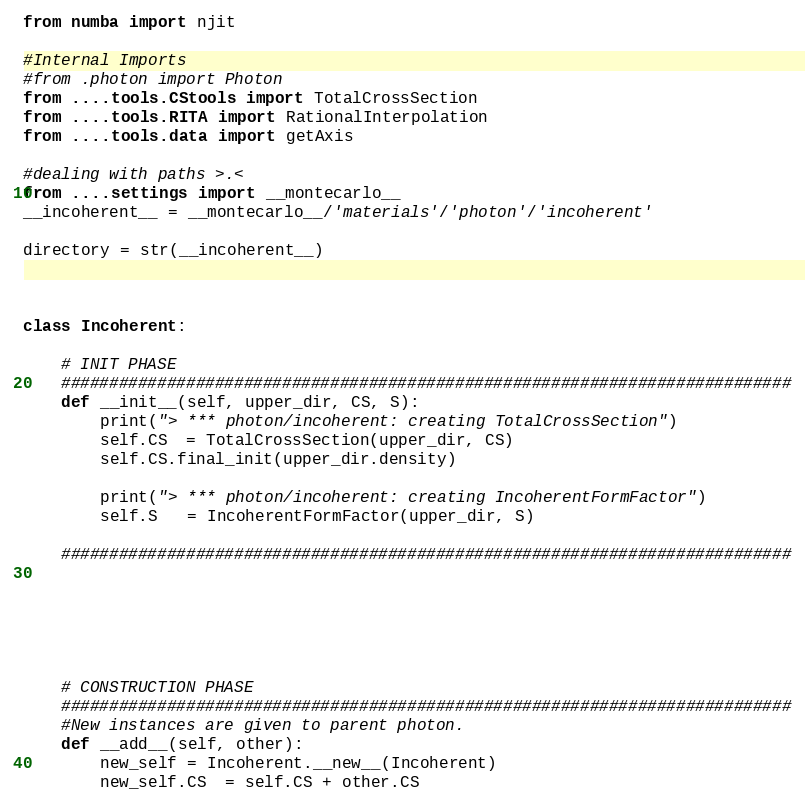<code> <loc_0><loc_0><loc_500><loc_500><_Python_>from numba import njit

#Internal Imports
#from .photon import Photon
from ....tools.CStools import TotalCrossSection
from ....tools.RITA import RationalInterpolation
from ....tools.data import getAxis

#dealing with paths >.<
from ....settings import __montecarlo__
__incoherent__ = __montecarlo__/'materials'/'photon'/'incoherent'

directory = str(__incoherent__)



class Incoherent:

	# INIT PHASE
	############################################################################
	def __init__(self, upper_dir, CS, S):
		print("> *** photon/incoherent: creating TotalCrossSection")
		self.CS  = TotalCrossSection(upper_dir, CS)
		self.CS.final_init(upper_dir.density)

		print("> *** photon/incoherent: creating IncoherentFormFactor")
		self.S   = IncoherentFormFactor(upper_dir, S)

	############################################################################






	# CONSTRUCTION PHASE
	############################################################################
	#New instances are given to parent photon.
	def __add__(self, other):
		new_self = Incoherent.__new__(Incoherent)
		new_self.CS  = self.CS + other.CS</code> 